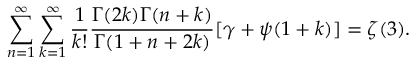Convert formula to latex. <formula><loc_0><loc_0><loc_500><loc_500>\sum _ { n = 1 } ^ { \infty } \sum _ { k = 1 } ^ { \infty } \frac { 1 } { k ! } \frac { \Gamma ( 2 k ) \Gamma ( n + k ) } { \Gamma ( 1 + n + 2 k ) } [ \gamma + \psi ( 1 + k ) ] = \zeta ( 3 ) .</formula> 